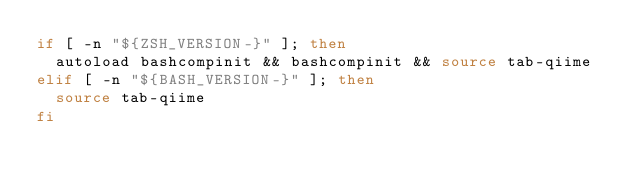<code> <loc_0><loc_0><loc_500><loc_500><_Bash_>if [ -n "${ZSH_VERSION-}" ]; then
  autoload bashcompinit && bashcompinit && source tab-qiime
elif [ -n "${BASH_VERSION-}" ]; then
  source tab-qiime
fi
</code> 